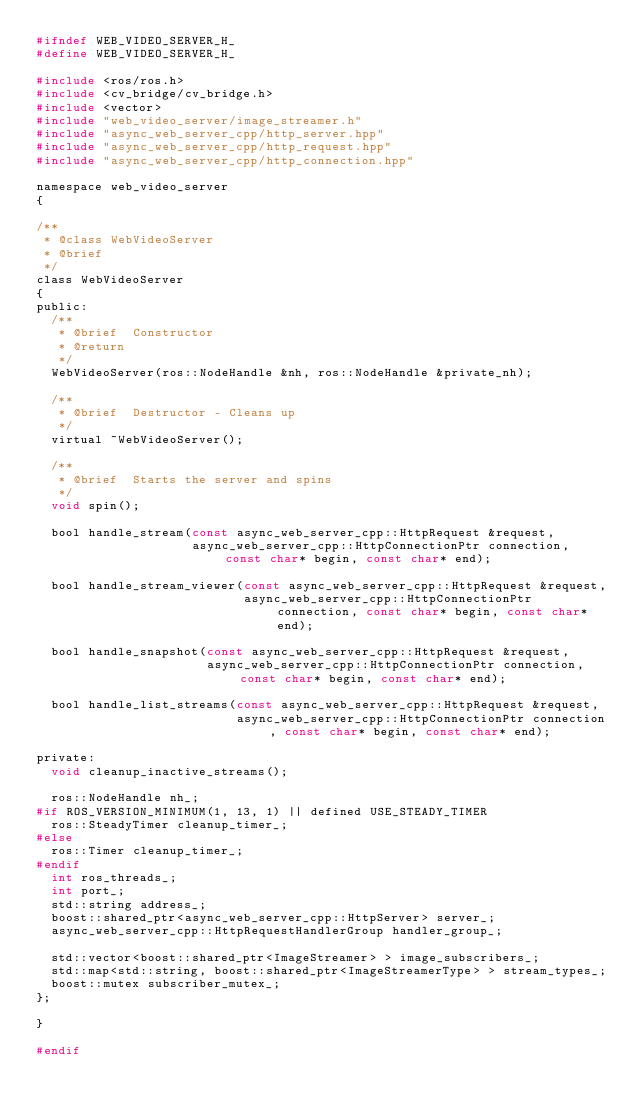<code> <loc_0><loc_0><loc_500><loc_500><_C_>#ifndef WEB_VIDEO_SERVER_H_
#define WEB_VIDEO_SERVER_H_

#include <ros/ros.h>
#include <cv_bridge/cv_bridge.h>
#include <vector>
#include "web_video_server/image_streamer.h"
#include "async_web_server_cpp/http_server.hpp"
#include "async_web_server_cpp/http_request.hpp"
#include "async_web_server_cpp/http_connection.hpp"

namespace web_video_server
{

/**
 * @class WebVideoServer
 * @brief
 */
class WebVideoServer
{
public:
  /**
   * @brief  Constructor
   * @return
   */
  WebVideoServer(ros::NodeHandle &nh, ros::NodeHandle &private_nh);

  /**
   * @brief  Destructor - Cleans up
   */
  virtual ~WebVideoServer();

  /**
   * @brief  Starts the server and spins
   */
  void spin();

  bool handle_stream(const async_web_server_cpp::HttpRequest &request,
                     async_web_server_cpp::HttpConnectionPtr connection, const char* begin, const char* end);

  bool handle_stream_viewer(const async_web_server_cpp::HttpRequest &request,
                            async_web_server_cpp::HttpConnectionPtr connection, const char* begin, const char* end);

  bool handle_snapshot(const async_web_server_cpp::HttpRequest &request,
                       async_web_server_cpp::HttpConnectionPtr connection, const char* begin, const char* end);

  bool handle_list_streams(const async_web_server_cpp::HttpRequest &request,
                           async_web_server_cpp::HttpConnectionPtr connection, const char* begin, const char* end);

private:
  void cleanup_inactive_streams();

  ros::NodeHandle nh_;
#if ROS_VERSION_MINIMUM(1, 13, 1) || defined USE_STEADY_TIMER
  ros::SteadyTimer cleanup_timer_;
#else
  ros::Timer cleanup_timer_;
#endif
  int ros_threads_;
  int port_;
  std::string address_;
  boost::shared_ptr<async_web_server_cpp::HttpServer> server_;
  async_web_server_cpp::HttpRequestHandlerGroup handler_group_;

  std::vector<boost::shared_ptr<ImageStreamer> > image_subscribers_;
  std::map<std::string, boost::shared_ptr<ImageStreamerType> > stream_types_;
  boost::mutex subscriber_mutex_;
};

}

#endif
</code> 